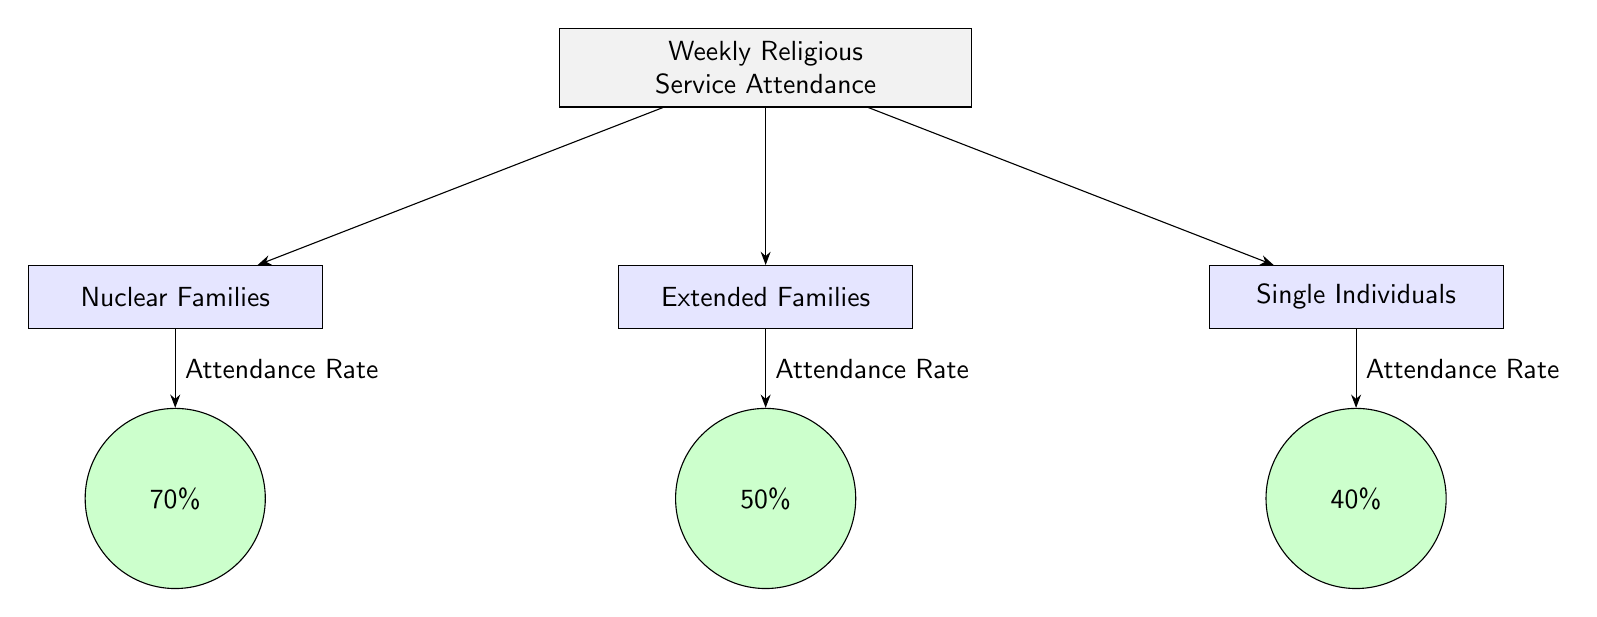What is the attendance rate for nuclear families? The diagram indicates that the attendance rate for nuclear families is represented by the node directly below "Nuclear Families," which states "70%."
Answer: 70% What family unit has the lowest attendance rate? To determine this, we examine the attendance rates listed for each family unit: nuclear families at 70%, extended families at 50%, and single individuals at 40%. The lowest is "single individuals" with an attendance rate of 40%.
Answer: Single Individuals How many family unit types are represented in the diagram? By counting the subnodes, we find three types of family units: nuclear families, extended families, and single individuals. Therefore, the total is three.
Answer: 3 What is the attendance rate for extended families? The attendance rate for extended families can be found in the node below "Extended Families," which shows "50%."
Answer: 50% Which family unit type has the highest attendance rate? The rates are compared: nuclear families at 70%, extended families at 50%, and single individuals at 40%. The highest rate is for nuclear families at 70%.
Answer: Nuclear Families What relationship does the arrow from "Weekly Religious Service Attendance" to "Nuclear Families" indicate? The arrow signifies that nuclear families are a category of those who attend weekly religious services, indicating a direct relationship between the services attendance and this family type.
Answer: Attendance Relationship How many edges are there in this diagram connecting family units to attendance rates? For each family unit, there is an arrow leading to its corresponding attendance rate. There are three family units, each with one connecting edge, leading to a total of three edges.
Answer: 3 What does the rate of 40% represent in the diagram? The rate of 40% is designated below the node for "Single Individuals," indicating their attendance rate for weekly religious services.
Answer: 40% 